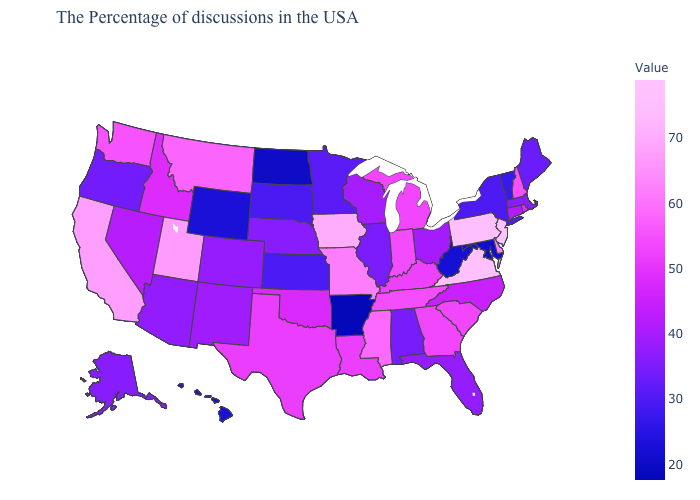Does Georgia have a higher value than Maine?
Give a very brief answer. Yes. Among the states that border South Carolina , which have the highest value?
Be succinct. Georgia. Does Arkansas have the lowest value in the USA?
Give a very brief answer. Yes. 